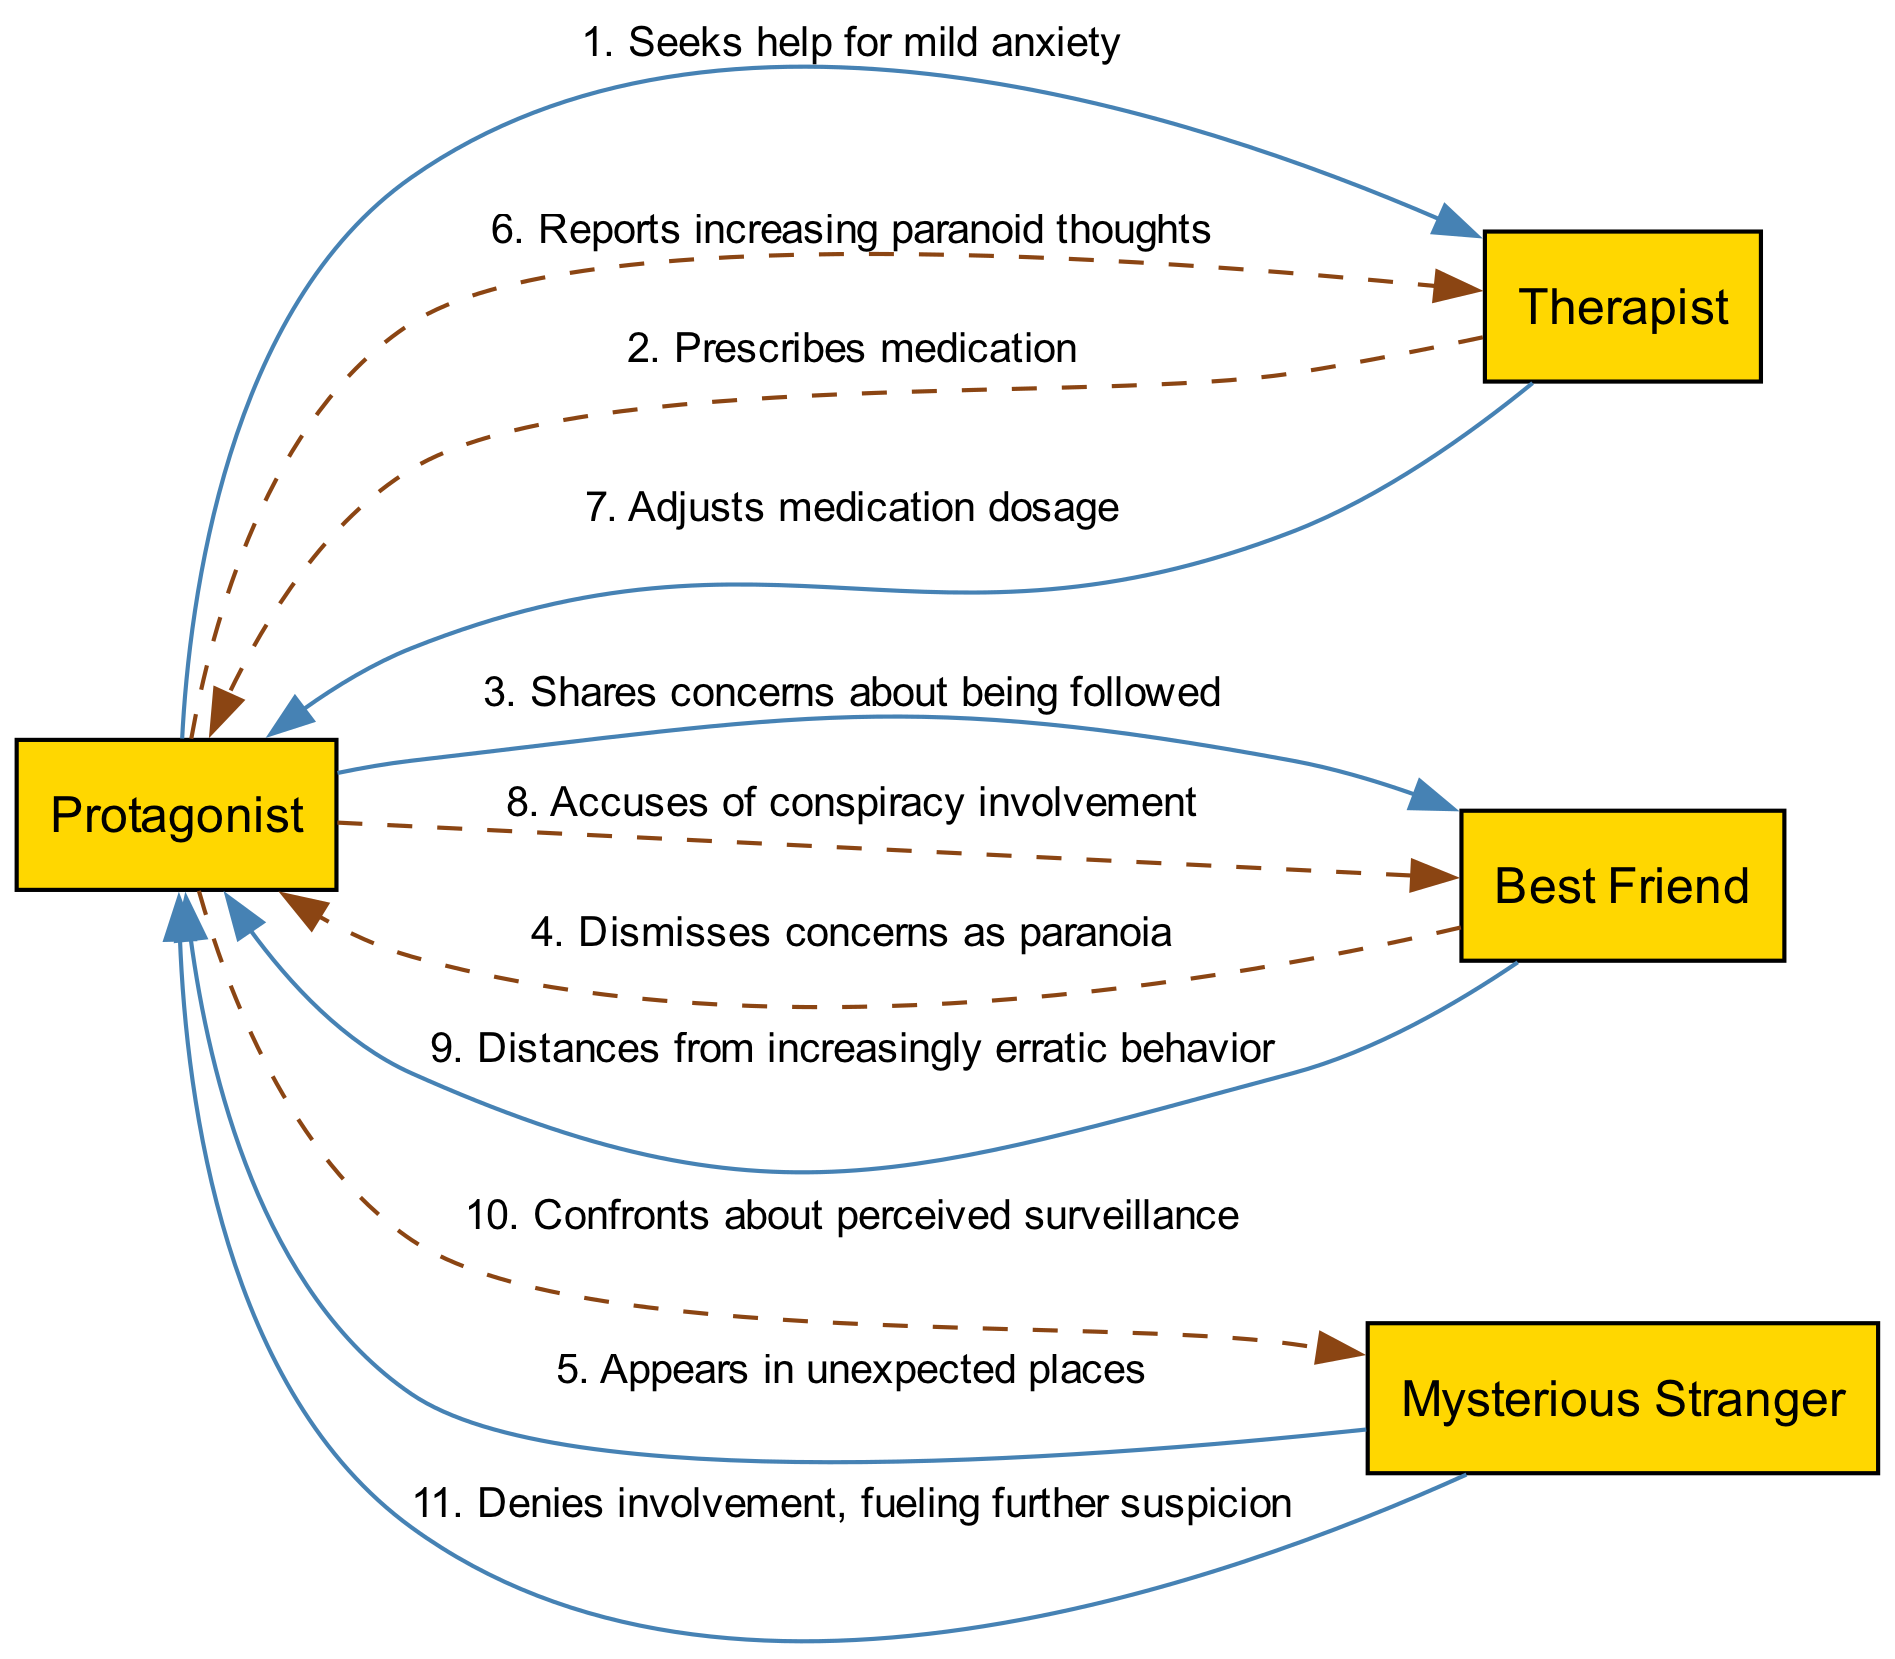What is the total number of actors in the diagram? There are four actors listed: Protagonist, Therapist, Best Friend, and Mysterious Stranger. Counting them gives us a total of four actors.
Answer: 4 Which actor does the protagonist seek help from? The sequence shows that the Protagonist first reaches out to the Therapist for help with anxiety.
Answer: Therapist What action does the Best Friend take after the Protagonist shares concerns? The Best Friend dismisses the Protagonist's concerns as paranoia, which is documented in the sequence.
Answer: Dismisses concerns as paranoia How many times does the Protagonist communicate with the Therapist? The Protagonist has two interactions with the Therapist: seeking help initially and reporting increasing paranoid thoughts later in the sequence.
Answer: 2 What does the Mysterious Stranger do in the sequence? The Mysterious Stranger appears in unexpected places, creating a sense of intrigue and suspicion.
Answer: Appears in unexpected places What accusation does the Protagonist make against the Best Friend? The Protagonist accuses the Best Friend of being involved in a conspiracy, indicating a breakdown in their relationship.
Answer: Accuses of conspiracy involvement What happens after the Protagonist confronts the Mysterious Stranger? The Mysterious Stranger denies any involvement, which fuels further suspicion in the Protagonist's mind, deepening the conflict.
Answer: Denies involvement, fueling further suspicion Which character becomes distant from the Protagonist due to erratic behavior? The Best Friend distances themselves from the Protagonist as a response to their increasingly erratic behavior.
Answer: Best Friend How does the therapist respond to the Protagonist's increasing paranoid thoughts? The Therapist adjusts the medication dosage for the Protagonist in response to their reports of intense paranoia.
Answer: Adjusts medication dosage 